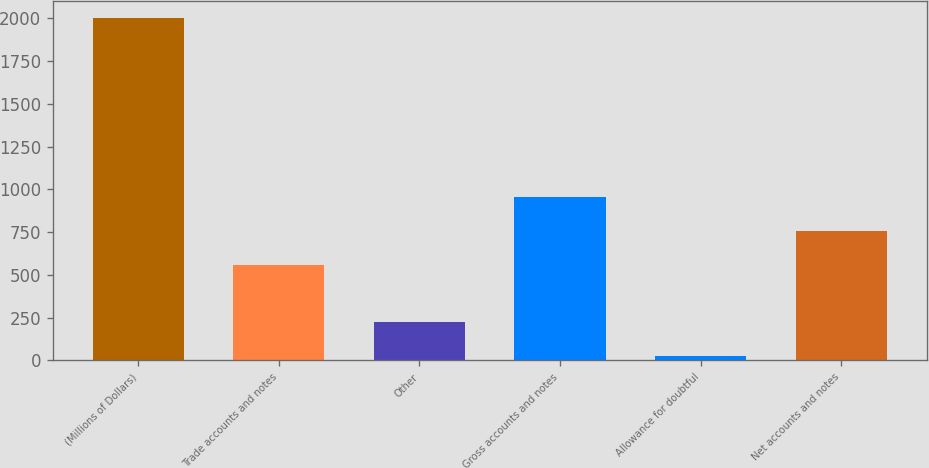Convert chart. <chart><loc_0><loc_0><loc_500><loc_500><bar_chart><fcel>(Millions of Dollars)<fcel>Trade accounts and notes<fcel>Other<fcel>Gross accounts and notes<fcel>Allowance for doubtful<fcel>Net accounts and notes<nl><fcel>2004<fcel>560<fcel>224.97<fcel>955.34<fcel>27.3<fcel>757.67<nl></chart> 